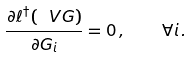<formula> <loc_0><loc_0><loc_500><loc_500>\frac { \partial \ell ^ { \dagger } ( \ V { G } ) } { \partial G _ { i } } = 0 \, , \quad \forall i \, .</formula> 